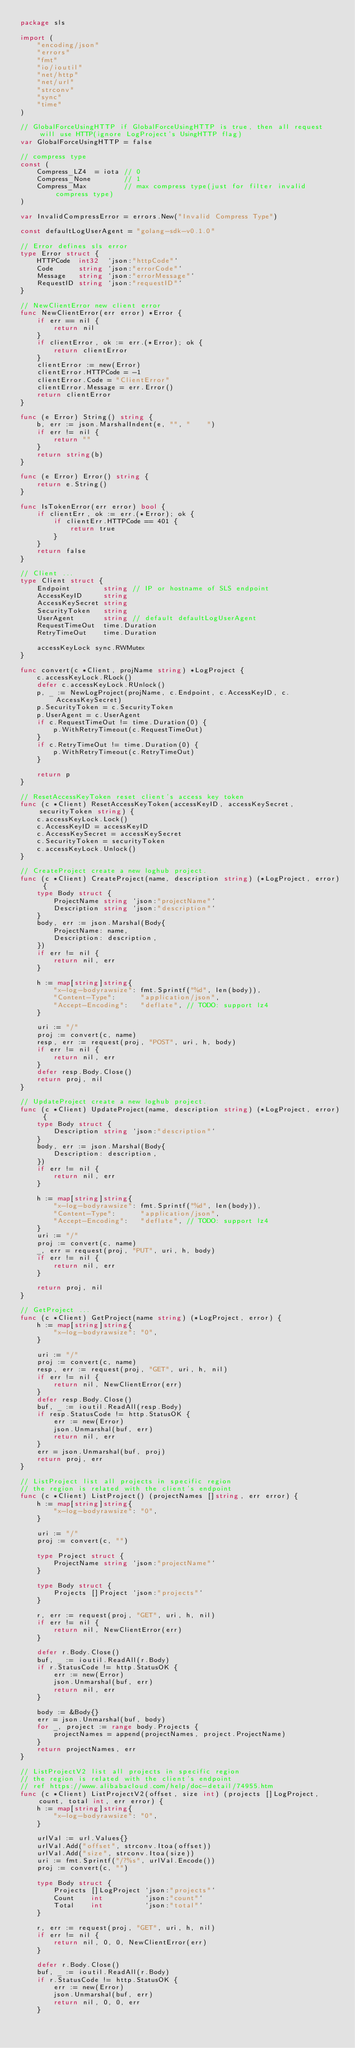Convert code to text. <code><loc_0><loc_0><loc_500><loc_500><_Go_>package sls

import (
	"encoding/json"
	"errors"
	"fmt"
	"io/ioutil"
	"net/http"
	"net/url"
	"strconv"
	"sync"
	"time"
)

// GlobalForceUsingHTTP if GlobalForceUsingHTTP is true, then all request will use HTTP(ignore LogProject's UsingHTTP flag)
var GlobalForceUsingHTTP = false

// compress type
const (
	Compress_LZ4  = iota // 0
	Compress_None        // 1
	Compress_Max         // max compress type(just for filter invalid compress type)
)

var InvalidCompressError = errors.New("Invalid Compress Type")

const defaultLogUserAgent = "golang-sdk-v0.1.0"

// Error defines sls error
type Error struct {
	HTTPCode  int32  `json:"httpCode"`
	Code      string `json:"errorCode"`
	Message   string `json:"errorMessage"`
	RequestID string `json:"requestID"`
}

// NewClientError new client error
func NewClientError(err error) *Error {
	if err == nil {
		return nil
	}
	if clientError, ok := err.(*Error); ok {
		return clientError
	}
	clientError := new(Error)
	clientError.HTTPCode = -1
	clientError.Code = "ClientError"
	clientError.Message = err.Error()
	return clientError
}

func (e Error) String() string {
	b, err := json.MarshalIndent(e, "", "    ")
	if err != nil {
		return ""
	}
	return string(b)
}

func (e Error) Error() string {
	return e.String()
}

func IsTokenError(err error) bool {
	if clientErr, ok := err.(*Error); ok {
		if clientErr.HTTPCode == 401 {
			return true
		}
	}
	return false
}

// Client ...
type Client struct {
	Endpoint        string // IP or hostname of SLS endpoint
	AccessKeyID     string
	AccessKeySecret string
	SecurityToken   string
	UserAgent       string // default defaultLogUserAgent
	RequestTimeOut  time.Duration
	RetryTimeOut 	time.Duration

	accessKeyLock sync.RWMutex
}

func convert(c *Client, projName string) *LogProject {
	c.accessKeyLock.RLock()
	defer c.accessKeyLock.RUnlock()
	p, _ := NewLogProject(projName, c.Endpoint, c.AccessKeyID, c.AccessKeySecret)
	p.SecurityToken = c.SecurityToken
	p.UserAgent = c.UserAgent
	if c.RequestTimeOut != time.Duration(0) {
		p.WithRetryTimeout(c.RequestTimeOut)
	}
	if c.RetryTimeOut != time.Duration(0) {
		p.WithRetryTimeout(c.RetryTimeOut)
	}

	return p
}

// ResetAccessKeyToken reset client's access key token
func (c *Client) ResetAccessKeyToken(accessKeyID, accessKeySecret, securityToken string) {
	c.accessKeyLock.Lock()
	c.AccessKeyID = accessKeyID
	c.AccessKeySecret = accessKeySecret
	c.SecurityToken = securityToken
	c.accessKeyLock.Unlock()
}

// CreateProject create a new loghub project.
func (c *Client) CreateProject(name, description string) (*LogProject, error) {
	type Body struct {
		ProjectName string `json:"projectName"`
		Description string `json:"description"`
	}
	body, err := json.Marshal(Body{
		ProjectName: name,
		Description: description,
	})
	if err != nil {
		return nil, err
	}

	h := map[string]string{
		"x-log-bodyrawsize": fmt.Sprintf("%d", len(body)),
		"Content-Type":      "application/json",
		"Accept-Encoding":   "deflate", // TODO: support lz4
	}

	uri := "/"
	proj := convert(c, name)
	resp, err := request(proj, "POST", uri, h, body)
	if err != nil {
		return nil, err
	}
	defer resp.Body.Close()
	return proj, nil
}

// UpdateProject create a new loghub project.
func (c *Client) UpdateProject(name, description string) (*LogProject, error) {
	type Body struct {
		Description string `json:"description"`
	}
	body, err := json.Marshal(Body{
		Description: description,
	})
	if err != nil {
		return nil, err
	}

	h := map[string]string{
		"x-log-bodyrawsize": fmt.Sprintf("%d", len(body)),
		"Content-Type":      "application/json",
		"Accept-Encoding":   "deflate", // TODO: support lz4
	}
	uri := "/"
	proj := convert(c, name)
	_, err = request(proj, "PUT", uri, h, body)
	if err != nil {
		return nil, err
	}

	return proj, nil
}

// GetProject ...
func (c *Client) GetProject(name string) (*LogProject, error) {
	h := map[string]string{
		"x-log-bodyrawsize": "0",
	}

	uri := "/"
	proj := convert(c, name)
	resp, err := request(proj, "GET", uri, h, nil)
	if err != nil {
		return nil, NewClientError(err)
	}
	defer resp.Body.Close()
	buf, _ := ioutil.ReadAll(resp.Body)
	if resp.StatusCode != http.StatusOK {
		err := new(Error)
		json.Unmarshal(buf, err)
		return nil, err
	}
	err = json.Unmarshal(buf, proj)
	return proj, err
}

// ListProject list all projects in specific region
// the region is related with the client's endpoint
func (c *Client) ListProject() (projectNames []string, err error) {
	h := map[string]string{
		"x-log-bodyrawsize": "0",
	}

	uri := "/"
	proj := convert(c, "")

	type Project struct {
		ProjectName string `json:"projectName"`
	}

	type Body struct {
		Projects []Project `json:"projects"`
	}

	r, err := request(proj, "GET", uri, h, nil)
	if err != nil {
		return nil, NewClientError(err)
	}

	defer r.Body.Close()
	buf, _ := ioutil.ReadAll(r.Body)
	if r.StatusCode != http.StatusOK {
		err := new(Error)
		json.Unmarshal(buf, err)
		return nil, err
	}

	body := &Body{}
	err = json.Unmarshal(buf, body)
	for _, project := range body.Projects {
		projectNames = append(projectNames, project.ProjectName)
	}
	return projectNames, err
}

// ListProjectV2 list all projects in specific region
// the region is related with the client's endpoint
// ref https://www.alibabacloud.com/help/doc-detail/74955.htm
func (c *Client) ListProjectV2(offset, size int) (projects []LogProject, count, total int, err error) {
	h := map[string]string{
		"x-log-bodyrawsize": "0",
	}

	urlVal := url.Values{}
	urlVal.Add("offset", strconv.Itoa(offset))
	urlVal.Add("size", strconv.Itoa(size))
	uri := fmt.Sprintf("/?%s", urlVal.Encode())
	proj := convert(c, "")

	type Body struct {
		Projects []LogProject `json:"projects"`
		Count    int          `json:"count"`
		Total    int          `json:"total"`
	}

	r, err := request(proj, "GET", uri, h, nil)
	if err != nil {
		return nil, 0, 0, NewClientError(err)
	}

	defer r.Body.Close()
	buf, _ := ioutil.ReadAll(r.Body)
	if r.StatusCode != http.StatusOK {
		err := new(Error)
		json.Unmarshal(buf, err)
		return nil, 0, 0, err
	}
</code> 